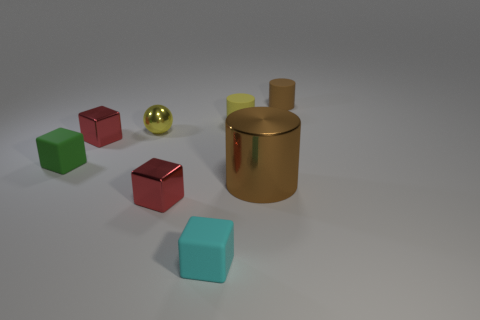Add 2 cyan objects. How many objects exist? 10 Subtract all yellow matte cylinders. How many cylinders are left? 2 Subtract all cyan cubes. How many cubes are left? 3 Subtract all spheres. How many objects are left? 7 Subtract 2 cubes. How many cubes are left? 2 Subtract all cyan cylinders. How many green blocks are left? 1 Subtract all tiny green spheres. Subtract all small metallic balls. How many objects are left? 7 Add 4 yellow metal balls. How many yellow metal balls are left? 5 Add 6 tiny red metallic blocks. How many tiny red metallic blocks exist? 8 Subtract 0 green cylinders. How many objects are left? 8 